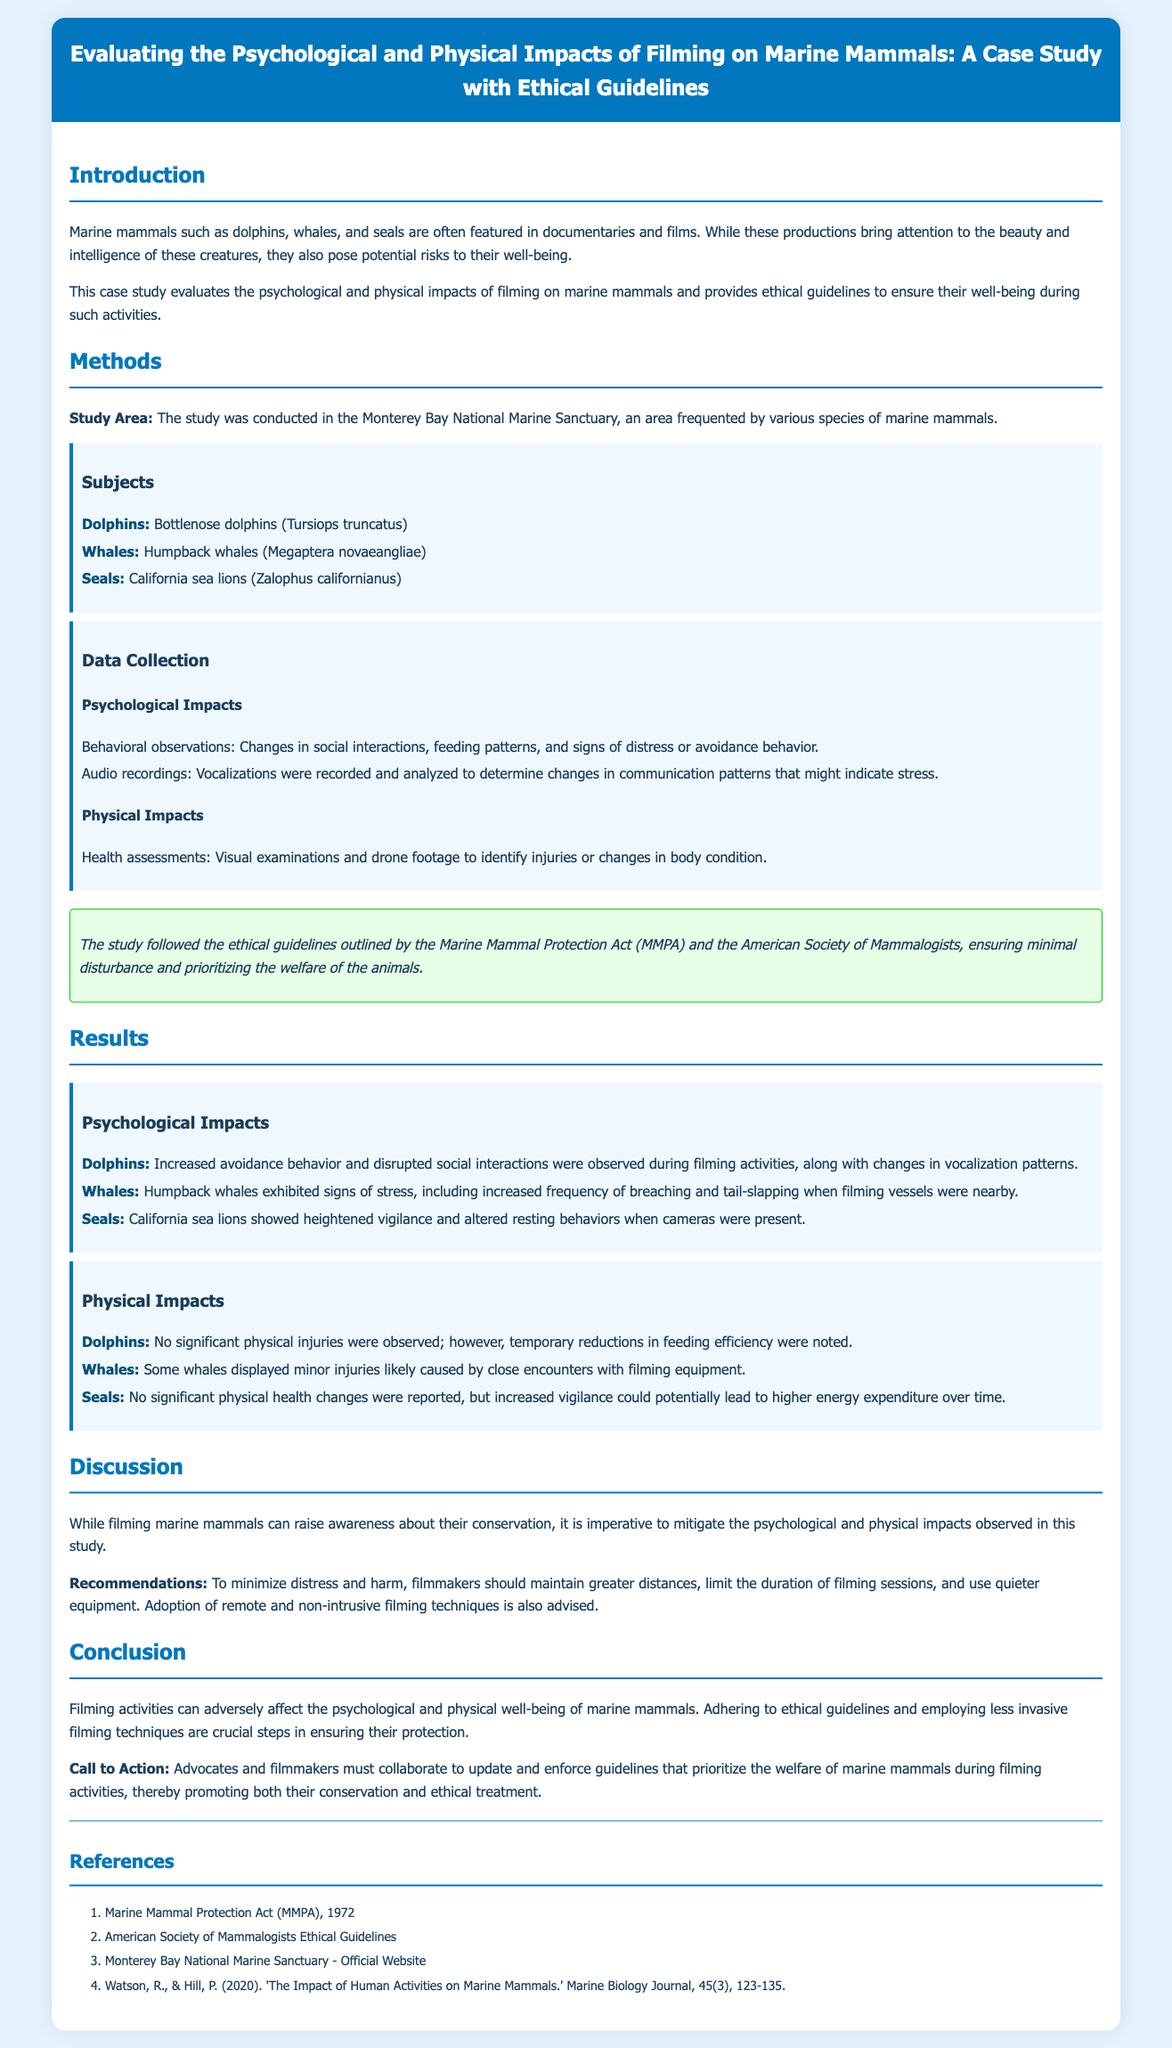what is the title of the study? The title is prominently displayed in the header section of the document.
Answer: Evaluating the Psychological and Physical Impacts of Filming on Marine Mammals: A Case Study with Ethical Guidelines which marine mammals were studied? The document lists specific species examined in the study.
Answer: Bottlenose dolphins, humpback whales, California sea lions what area was the study conducted in? The specific location of the study is mentioned under the methods section.
Answer: Monterey Bay National Marine Sanctuary what ethical guidelines were followed in the study? The ethical guidelines are referenced in the ethical note section of the document.
Answer: Marine Mammal Protection Act (MMPA) what behavioral change was observed in dolphins during filming? This detail is included in the results section, specifically under psychological impacts.
Answer: Increased avoidance behavior what recommendations were made to filmmakers? The discussion section summarizes suggestions for minimizing impacts during filming.
Answer: Maintain greater distances, limit filming duration how many references are listed in the document? The total number of listed references can be counted in the references section.
Answer: Four which species showed signs of stress while filming? The results section highlights specific responses from different marine mammals.
Answer: Humpback whales what was the conclusion of the study? The conclusion summarizes the overall findings and implications of the study.
Answer: Filming activities can adversely affect the psychological and physical well-being of marine mammals 